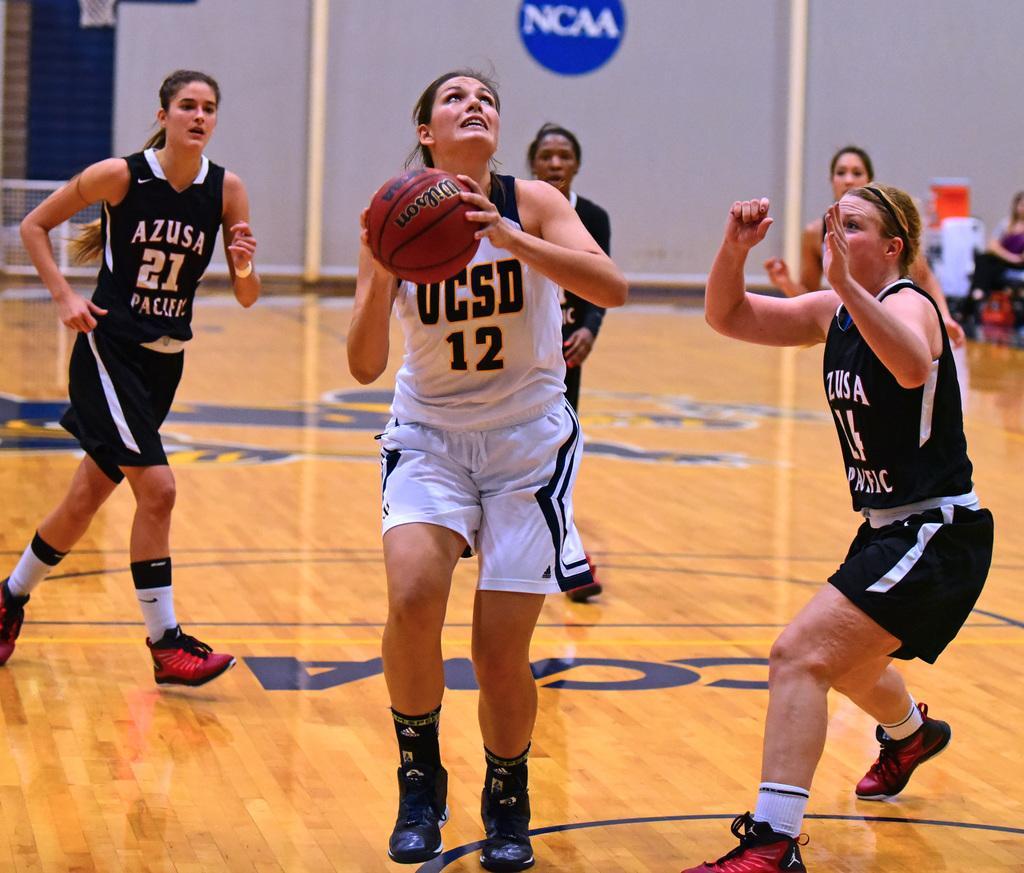Describe this image in one or two sentences. In the picture I can see five women standing on the wooden floor. They are wearing a sport dress. I can see a woman in the middle of the image and she is holding the basketball in her hands. 